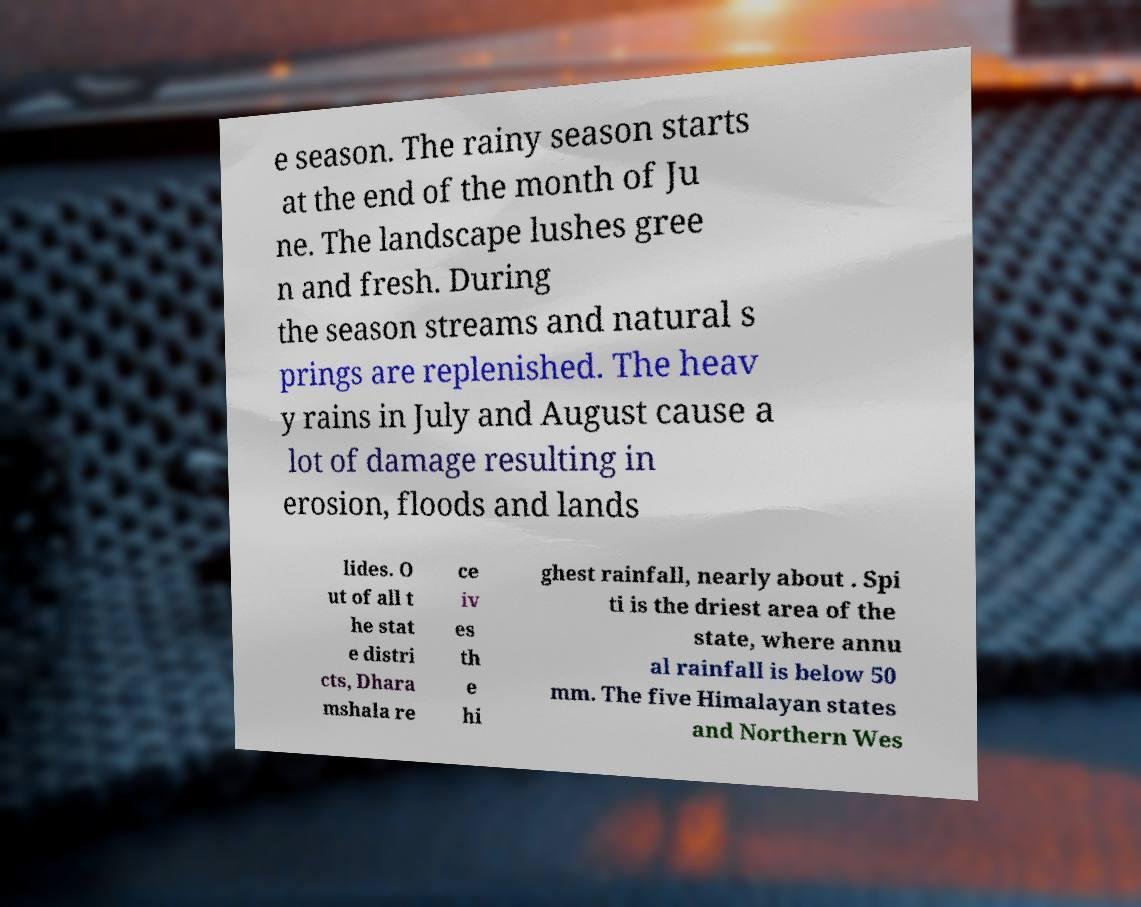Can you read and provide the text displayed in the image?This photo seems to have some interesting text. Can you extract and type it out for me? e season. The rainy season starts at the end of the month of Ju ne. The landscape lushes gree n and fresh. During the season streams and natural s prings are replenished. The heav y rains in July and August cause a lot of damage resulting in erosion, floods and lands lides. O ut of all t he stat e distri cts, Dhara mshala re ce iv es th e hi ghest rainfall, nearly about . Spi ti is the driest area of the state, where annu al rainfall is below 50 mm. The five Himalayan states and Northern Wes 